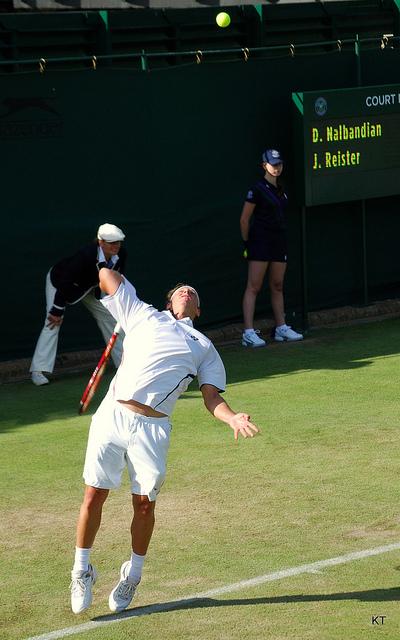What is the bottom name on the sign?
Be succinct. J reister. What is covering the man's hands?
Answer briefly. Nothing. What technique is being demonstrated?
Short answer required. Serve. What is in the picture?
Concise answer only. Tennis player. What color is his shirt?
Quick response, please. White. What is on the man's hand?
Keep it brief. Glove. 